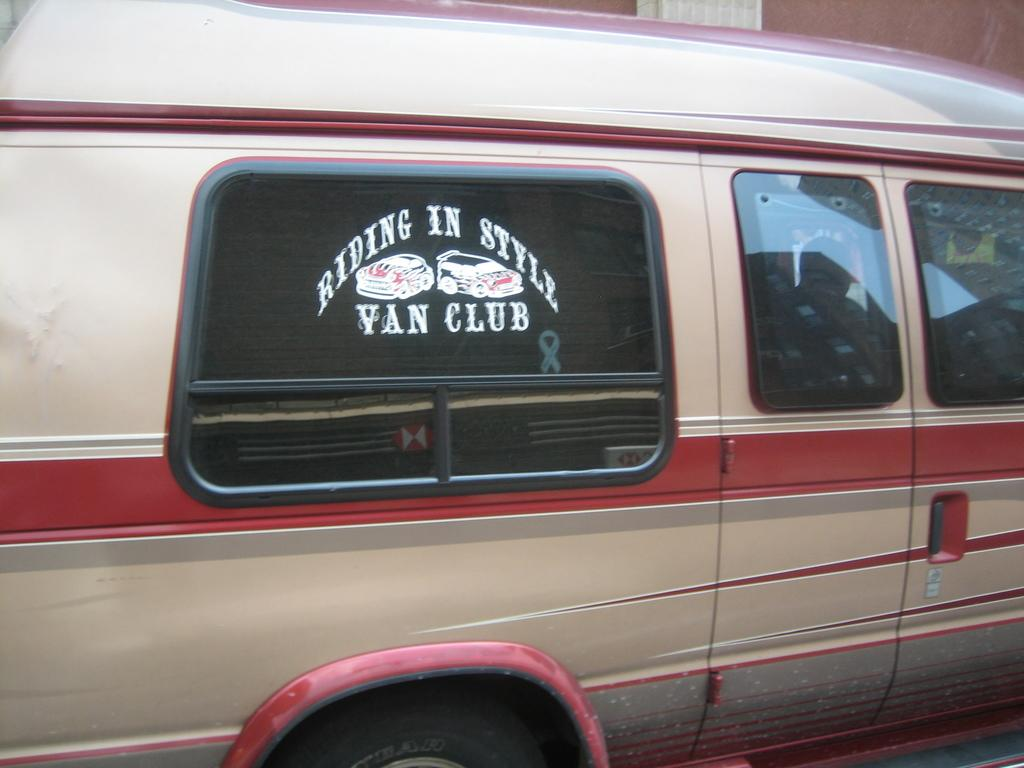<image>
Render a clear and concise summary of the photo. A van has "Riding in Style Van Club" stenciled on the window. 